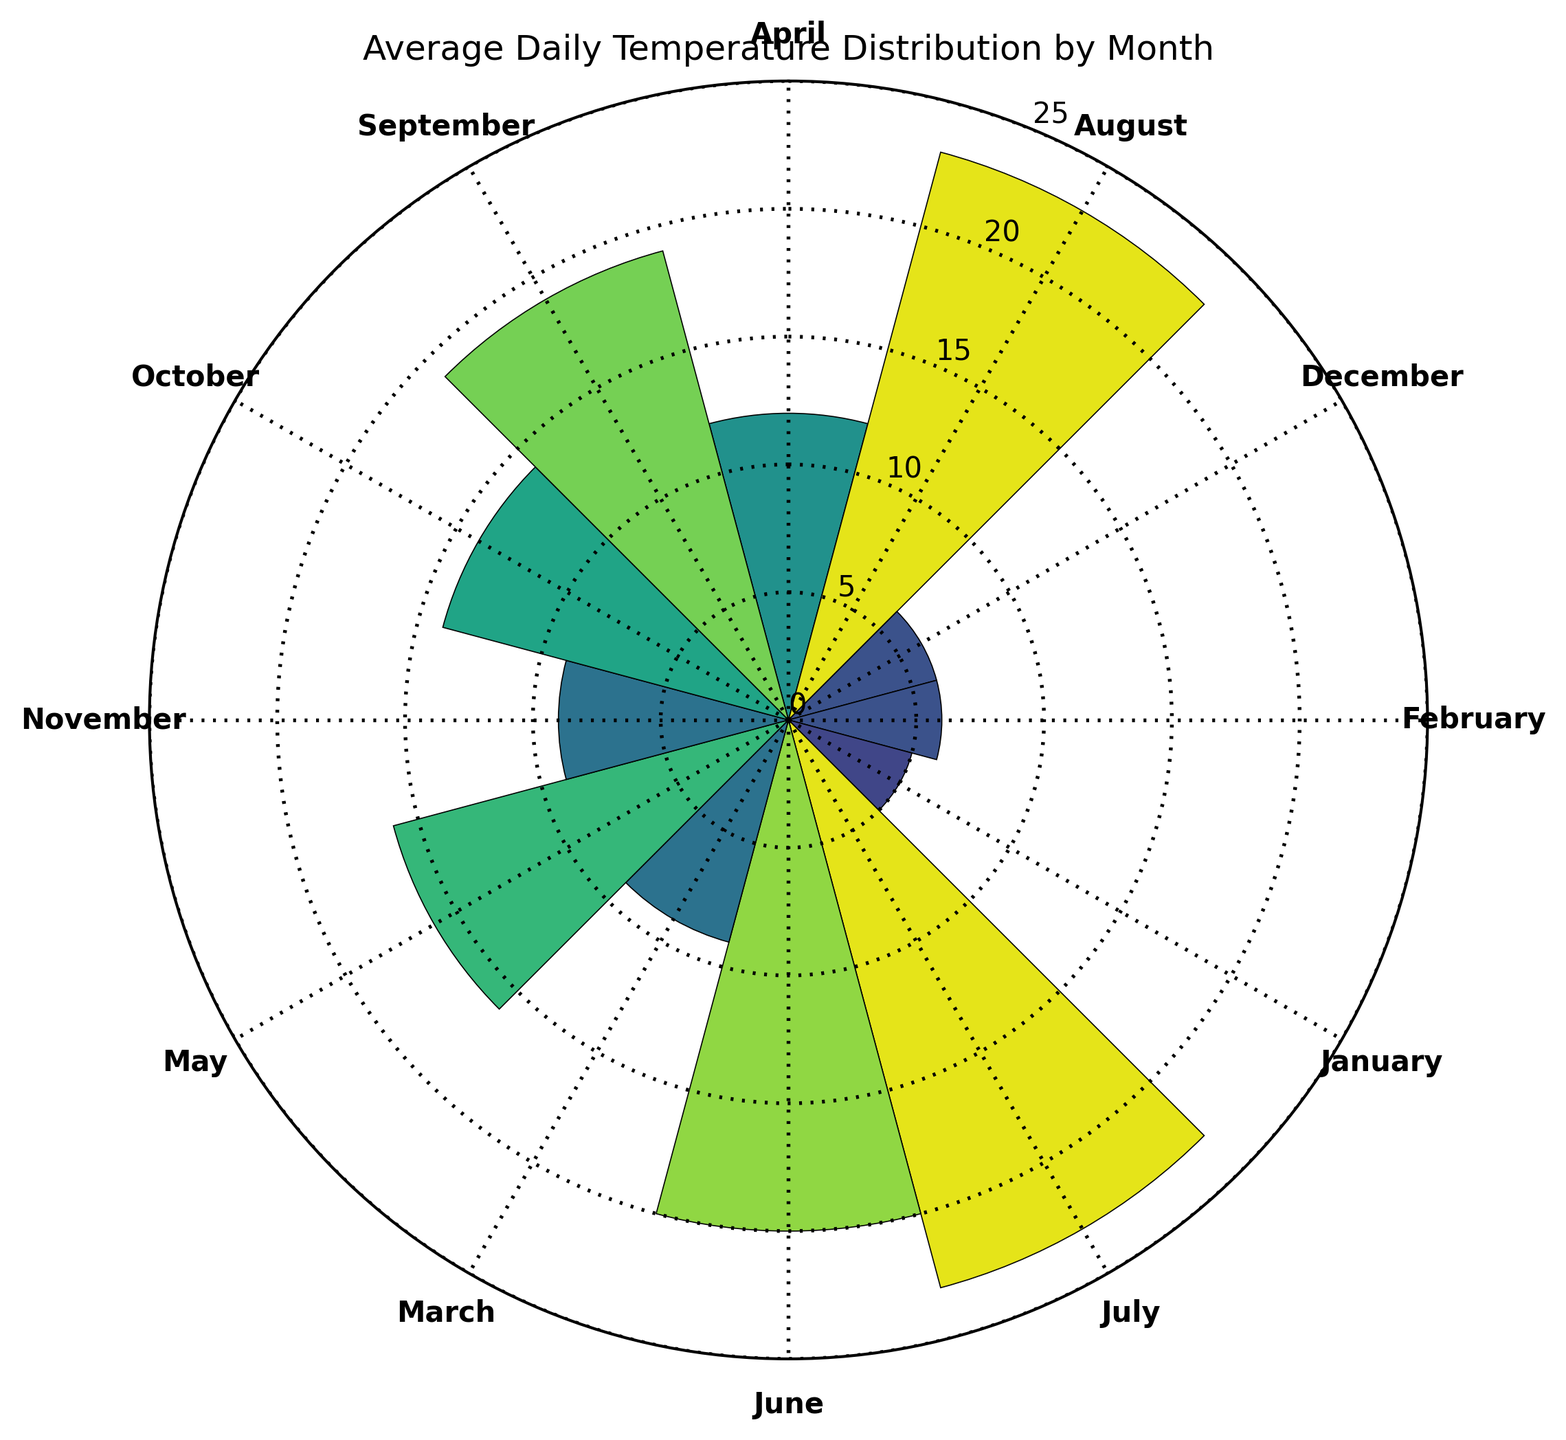What's the average temperature in July? To find the average temperature in July, locate July on the rose chart and note the length of the bar. The average temperature is represented by the height of the July segment.
Answer: 23°C Which month has the highest average temperature? To determine the month with the highest average temperature, identify the segment in the rose chart with the longest bar. The highest bar represents the month with the highest average temperature.
Answer: July and August Which months have an average temperature lower than 10°C? Look for segments in the rose chart where the bar height is below the 10°C ring. These segments indicate months with an average temperature lower than 10°C.
Answer: January, February, December, November What is the range of temperatures in the summer months (June, July, August)? Identify the segments for June, July, and August. Note the highest and lowest temperatures among these months. June averages 20°C, July averages 23°C, and August averages 23°C. The range is the difference between the maximum and minimum values.
Answer: 4°C Is there a month where the average temperature equals 12°C? Find any segment on the rose chart where the bar exactly reaches the 12°C ring. If one exists, that is the month where the average temperature equals 12°C.
Answer: April Which month has the lowest average temperature? Locate the segment with the shortest bar on the rose chart. The month corresponding to this bar has the lowest average temperature.
Answer: January How does the average temperature in February compare to that in March? Compare the heights of the segments for February and March. February's bar is lower than March's, indicating February has a lower average temperature.
Answer: February is cooler than March Between April and October, which month has a higher average temperature? Compare the bar heights for April and October. The taller bar represents the month with the higher average temperature.
Answer: April What is the median average temperature of all the months? First, list the average temperatures in ascending order. Since there are an even number of months, the median is the average of the 6th and 7th values in this sorted list.
Answer: 13.5°C What's the total sum of the average temperatures for the spring months (March, April, May)? Add the average temperatures for March (9°C), April (12°C), and May (16°C).
Answer: 37°C 